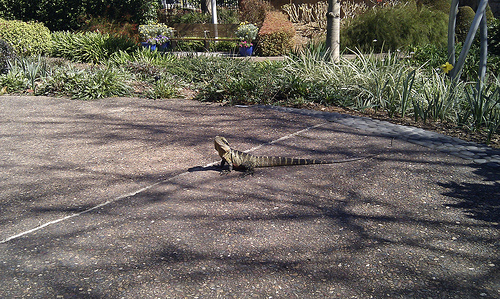<image>
Is there a lizard in the grass? No. The lizard is not contained within the grass. These objects have a different spatial relationship. 